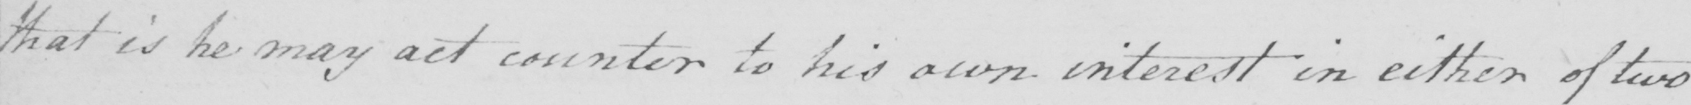What does this handwritten line say? that is he may act counter to his own interest in either of two 